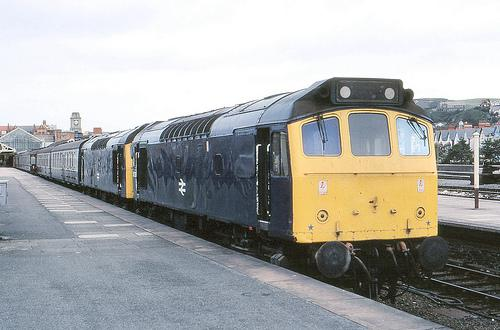Question: where is this taking place?
Choices:
A. The bus station.
B. The airport.
C. Train station.
D. The mine.
Answer with the letter. Answer: C Question: what kind of vehicle is this?
Choices:
A. Car.
B. Bus.
C. Plane.
D. Train.
Answer with the letter. Answer: D Question: what color is the train?
Choices:
A. Yellow and black.
B. Silver.
C. Green.
D. Brown.
Answer with the letter. Answer: A Question: what is the train next to?
Choices:
A. Platform.
B. Benches.
C. The stop sign.
D. People waiting to board.
Answer with the letter. Answer: A Question: what is the train travelling on?
Choices:
A. Train tracks.
B. A bridge.
C. An overpass.
D. The grass.
Answer with the letter. Answer: A Question: how many windshield wipers are on the front of the train in the photo?
Choices:
A. One.
B. Three.
C. Two.
D. Four.
Answer with the letter. Answer: C 